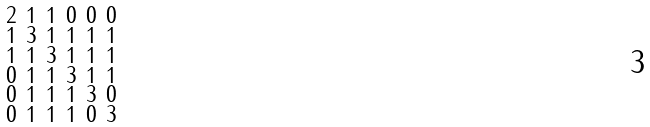Convert formula to latex. <formula><loc_0><loc_0><loc_500><loc_500>\begin{smallmatrix} 2 & 1 & 1 & 0 & 0 & 0 \\ 1 & 3 & 1 & 1 & 1 & 1 \\ 1 & 1 & 3 & 1 & 1 & 1 \\ 0 & 1 & 1 & 3 & 1 & 1 \\ 0 & 1 & 1 & 1 & 3 & 0 \\ 0 & 1 & 1 & 1 & 0 & 3 \end{smallmatrix}</formula> 